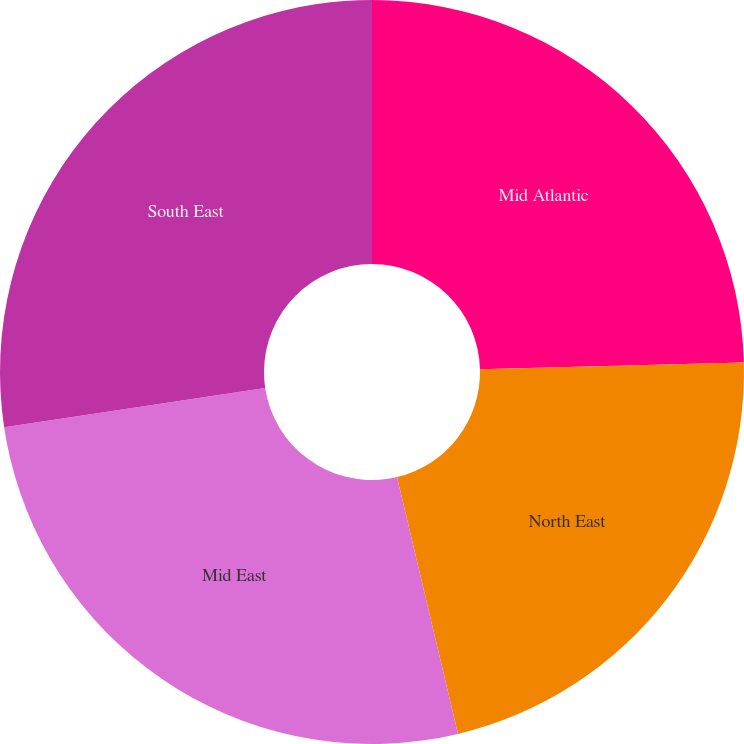<chart> <loc_0><loc_0><loc_500><loc_500><pie_chart><fcel>Mid Atlantic<fcel>North East<fcel>Mid East<fcel>South East<nl><fcel>24.6%<fcel>21.69%<fcel>26.35%<fcel>27.37%<nl></chart> 